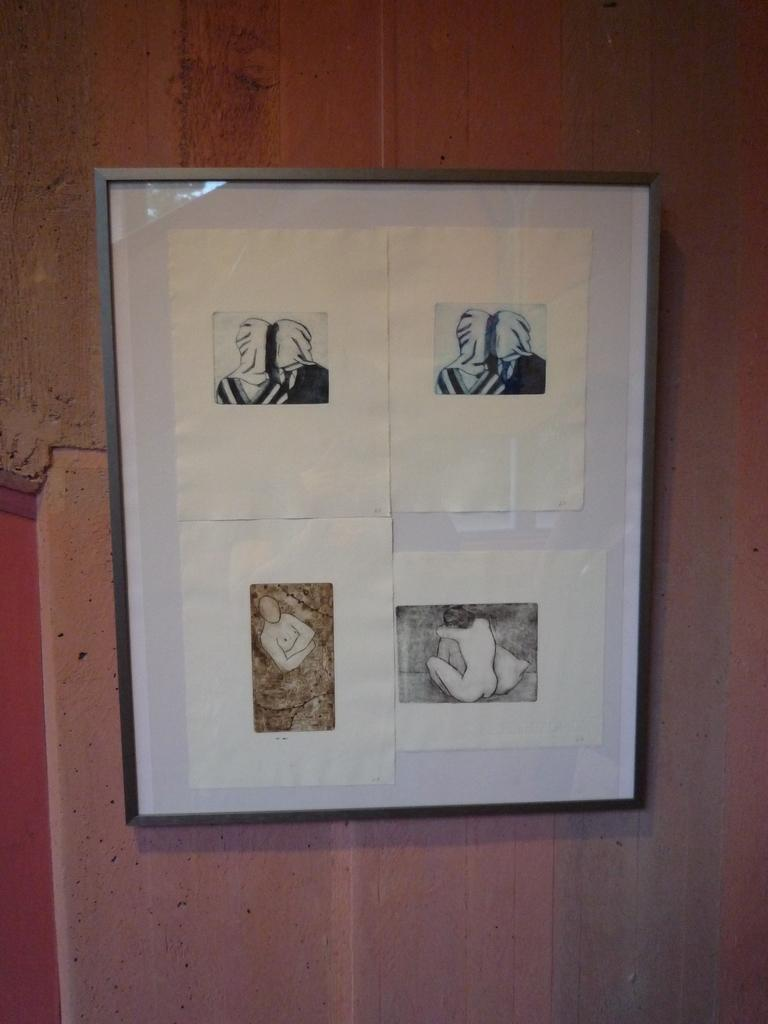What type of wall is visible in the image? There is a wooden wall in the image. What is attached to the wooden wall? There is a photo frame on the image frame on the wall. How many images are present in the photo frame? The photo frame contains four images. Where is the lunchroom located in the image? There is no mention of a lunchroom in the image; it only features a wooden wall with a photo frame. What type of book is placed on the wooden wall? There is no book present in the image; it only features a wooden wall with a photo frame. 